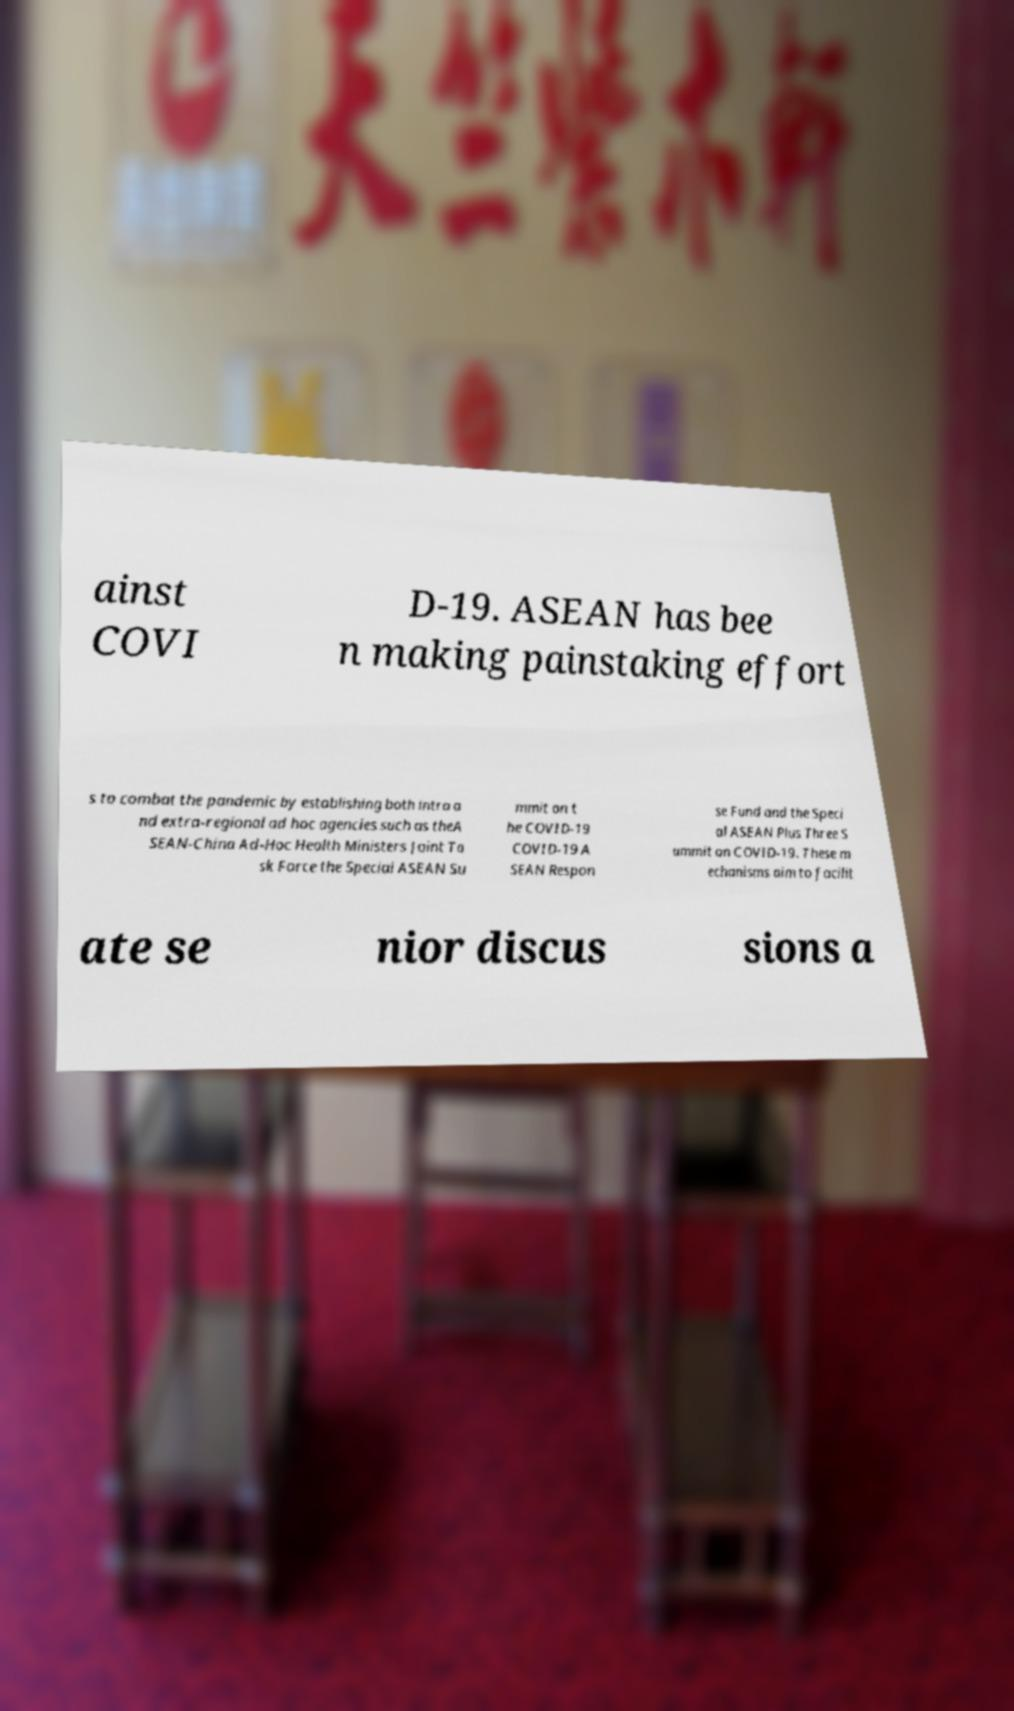For documentation purposes, I need the text within this image transcribed. Could you provide that? ainst COVI D-19. ASEAN has bee n making painstaking effort s to combat the pandemic by establishing both intra a nd extra-regional ad hoc agencies such as theA SEAN-China Ad-Hoc Health Ministers Joint Ta sk Force the Special ASEAN Su mmit on t he COVID-19 COVID-19 A SEAN Respon se Fund and the Speci al ASEAN Plus Three S ummit on COVID-19. These m echanisms aim to facilit ate se nior discus sions a 